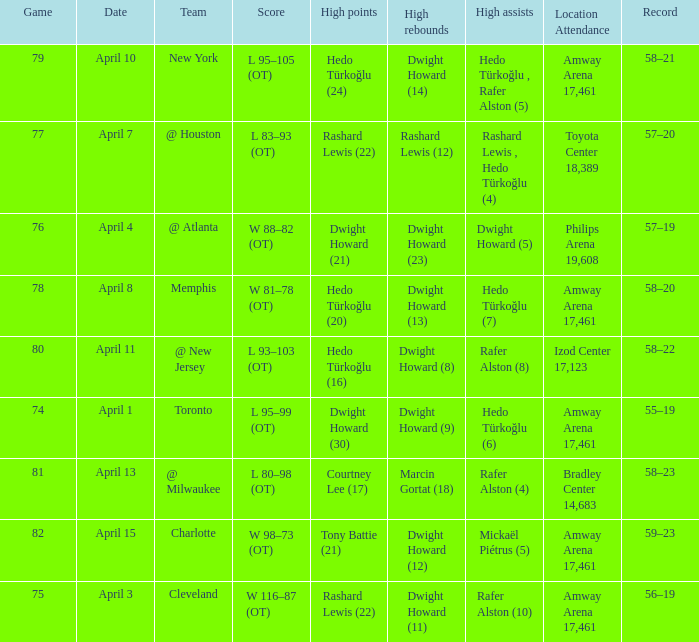What is the highest rebounds for game 81? Marcin Gortat (18). 